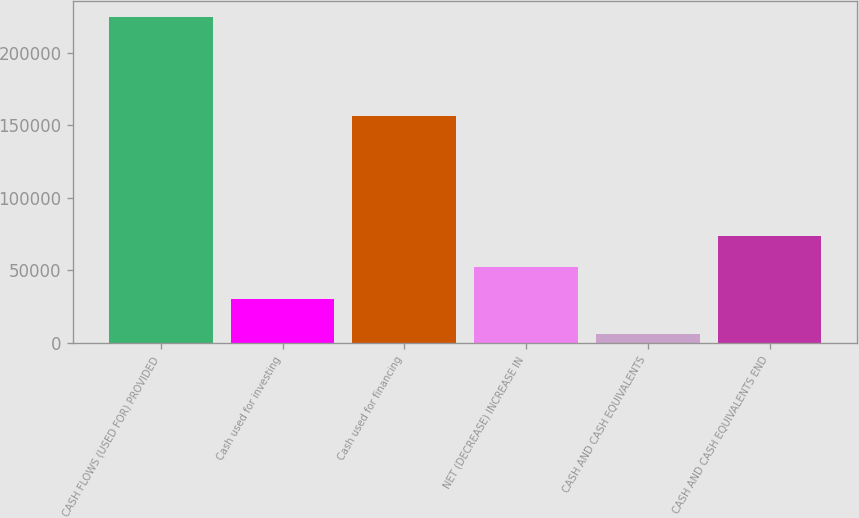Convert chart. <chart><loc_0><loc_0><loc_500><loc_500><bar_chart><fcel>CASH FLOWS (USED FOR) PROVIDED<fcel>Cash used for investing<fcel>Cash used for financing<fcel>NET (DECREASE) INCREASE IN<fcel>CASH AND CASH EQUIVALENTS<fcel>CASH AND CASH EQUIVALENTS END<nl><fcel>224524<fcel>30278<fcel>156447<fcel>52113<fcel>6174<fcel>73948<nl></chart> 